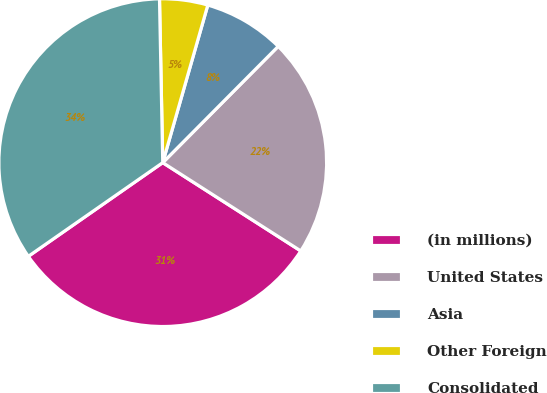Convert chart to OTSL. <chart><loc_0><loc_0><loc_500><loc_500><pie_chart><fcel>(in millions)<fcel>United States<fcel>Asia<fcel>Other Foreign<fcel>Consolidated<nl><fcel>31.25%<fcel>21.61%<fcel>8.01%<fcel>4.75%<fcel>34.37%<nl></chart> 